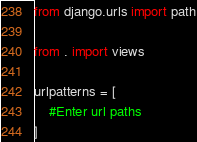Convert code to text. <code><loc_0><loc_0><loc_500><loc_500><_Python_>from django.urls import path

from . import views

urlpatterns = [
    #Enter url paths
]</code> 